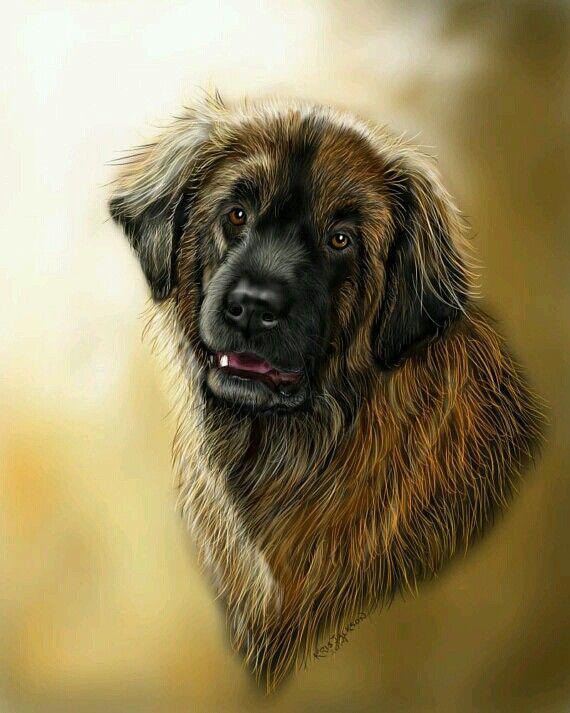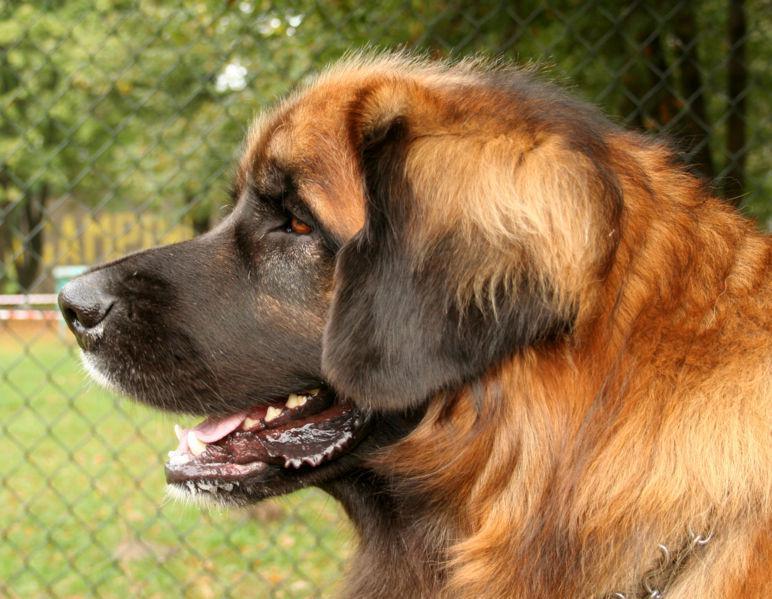The first image is the image on the left, the second image is the image on the right. For the images shown, is this caption "An image includes a furry dog lying on green foliage." true? Answer yes or no. No. The first image is the image on the left, the second image is the image on the right. For the images displayed, is the sentence "There are three or more dogs." factually correct? Answer yes or no. No. 